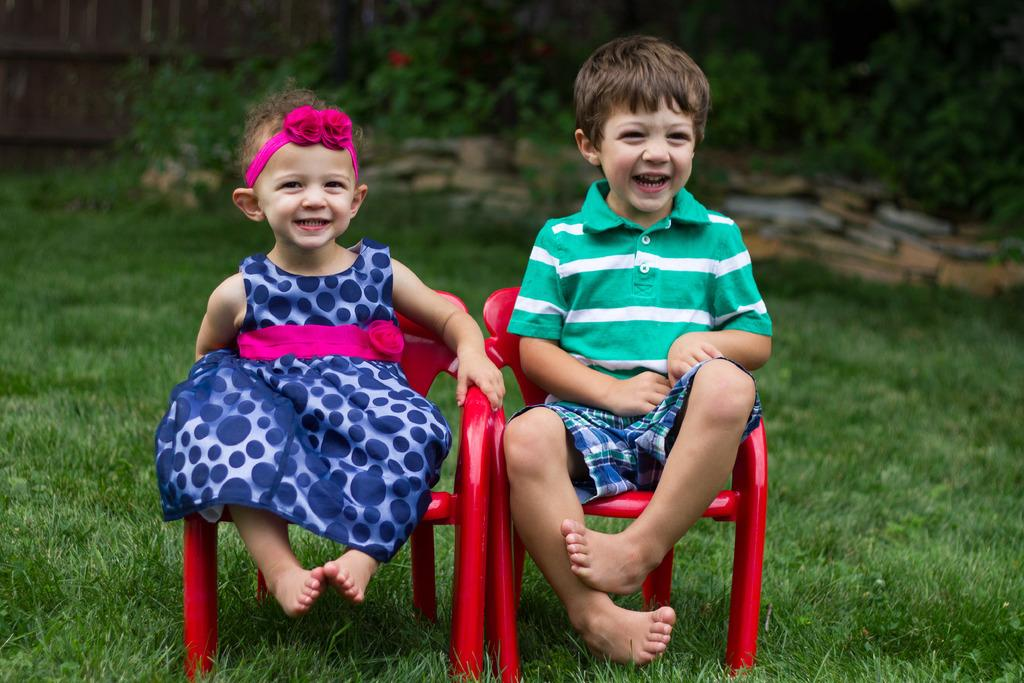How many kids are in the image? There are two kids in the image. What are the kids sitting on? The kids are sitting on a red chair. What type of surface is visible beneath the kids? The ground is covered with grass. Where is the dock located in the image? There is no dock present in the image. Is there a bath visible in the image? There is no bath present in the image. 